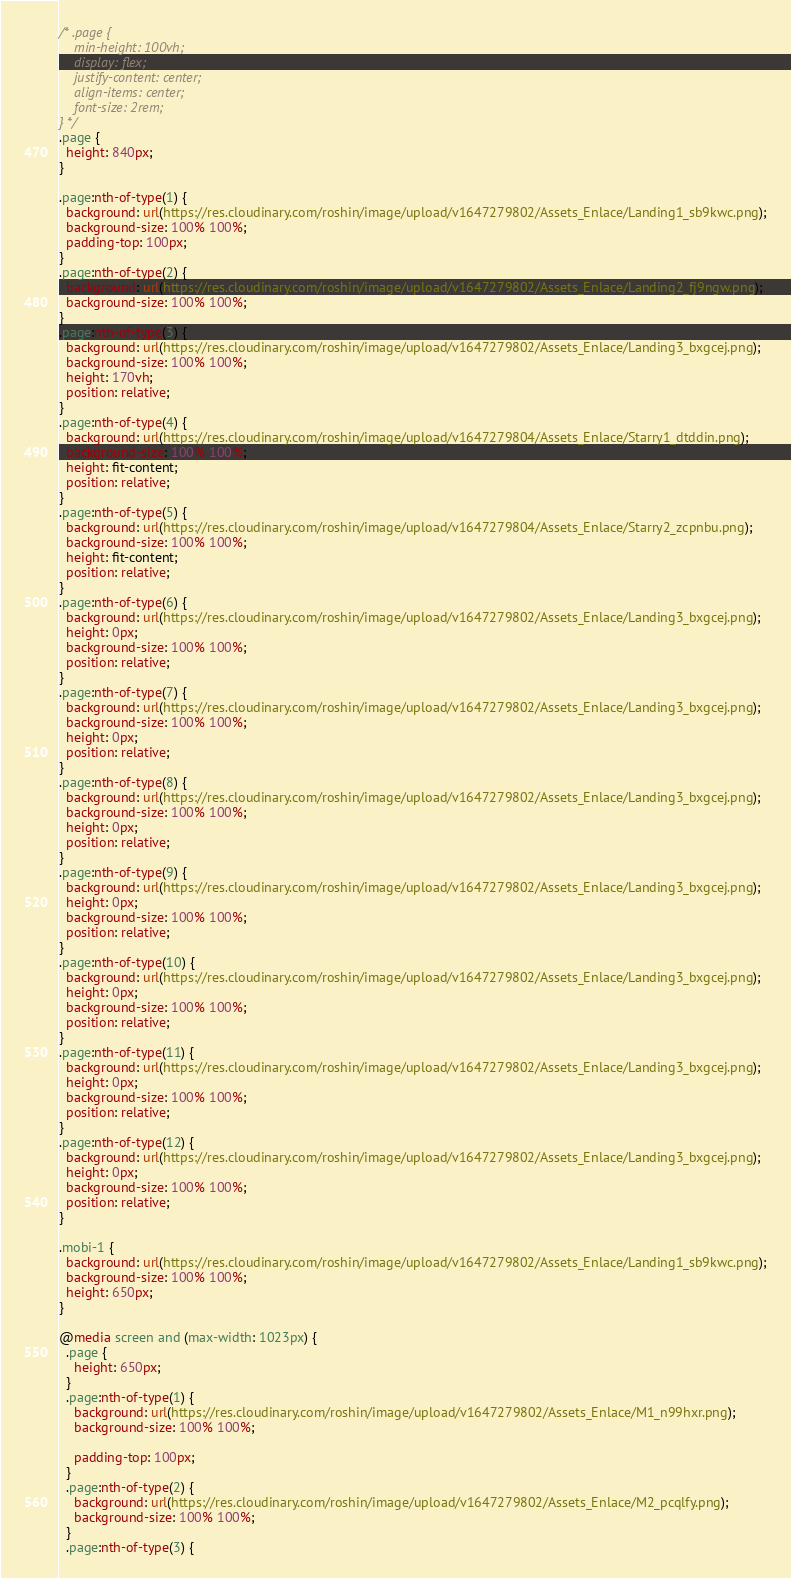<code> <loc_0><loc_0><loc_500><loc_500><_CSS_>/* .page {
	min-height: 100vh;
	display: flex;
	justify-content: center;
	align-items: center;
	font-size: 2rem;
} */
.page {
  height: 840px;
}

.page:nth-of-type(1) {
  background: url(https://res.cloudinary.com/roshin/image/upload/v1647279802/Assets_Enlace/Landing1_sb9kwc.png);
  background-size: 100% 100%;
  padding-top: 100px;
}
.page:nth-of-type(2) {
  background: url(https://res.cloudinary.com/roshin/image/upload/v1647279802/Assets_Enlace/Landing2_fj9ngw.png);
  background-size: 100% 100%;
}
.page:nth-of-type(3) {
  background: url(https://res.cloudinary.com/roshin/image/upload/v1647279802/Assets_Enlace/Landing3_bxgcej.png);
  background-size: 100% 100%;
  height: 170vh;
  position: relative;
}
.page:nth-of-type(4) {
  background: url(https://res.cloudinary.com/roshin/image/upload/v1647279804/Assets_Enlace/Starry1_dtddin.png);
  background-size: 100% 100%;
  height: fit-content;
  position: relative;
}
.page:nth-of-type(5) {
  background: url(https://res.cloudinary.com/roshin/image/upload/v1647279804/Assets_Enlace/Starry2_zcpnbu.png);
  background-size: 100% 100%;
  height: fit-content;
  position: relative;
}
.page:nth-of-type(6) {
  background: url(https://res.cloudinary.com/roshin/image/upload/v1647279802/Assets_Enlace/Landing3_bxgcej.png);
  height: 0px;
  background-size: 100% 100%;
  position: relative;
}
.page:nth-of-type(7) {
  background: url(https://res.cloudinary.com/roshin/image/upload/v1647279802/Assets_Enlace/Landing3_bxgcej.png);
  background-size: 100% 100%;
  height: 0px;
  position: relative;
}
.page:nth-of-type(8) {
  background: url(https://res.cloudinary.com/roshin/image/upload/v1647279802/Assets_Enlace/Landing3_bxgcej.png);
  background-size: 100% 100%;
  height: 0px;
  position: relative;
}
.page:nth-of-type(9) {
  background: url(https://res.cloudinary.com/roshin/image/upload/v1647279802/Assets_Enlace/Landing3_bxgcej.png);
  height: 0px;
  background-size: 100% 100%;
  position: relative;
}
.page:nth-of-type(10) {
  background: url(https://res.cloudinary.com/roshin/image/upload/v1647279802/Assets_Enlace/Landing3_bxgcej.png);
  height: 0px;
  background-size: 100% 100%;
  position: relative;
}
.page:nth-of-type(11) {
  background: url(https://res.cloudinary.com/roshin/image/upload/v1647279802/Assets_Enlace/Landing3_bxgcej.png);
  height: 0px;
  background-size: 100% 100%;
  position: relative;
}
.page:nth-of-type(12) {
  background: url(https://res.cloudinary.com/roshin/image/upload/v1647279802/Assets_Enlace/Landing3_bxgcej.png);
  height: 0px;
  background-size: 100% 100%;
  position: relative;
}

.mobi-1 {
  background: url(https://res.cloudinary.com/roshin/image/upload/v1647279802/Assets_Enlace/Landing1_sb9kwc.png);
  background-size: 100% 100%;
  height: 650px;
}

@media screen and (max-width: 1023px) {
  .page {
    height: 650px;
  }
  .page:nth-of-type(1) {
    background: url(https://res.cloudinary.com/roshin/image/upload/v1647279802/Assets_Enlace/M1_n99hxr.png);
    background-size: 100% 100%;

    padding-top: 100px;
  }
  .page:nth-of-type(2) {
    background: url(https://res.cloudinary.com/roshin/image/upload/v1647279802/Assets_Enlace/M2_pcqlfy.png);
    background-size: 100% 100%;
  }
  .page:nth-of-type(3) {</code> 